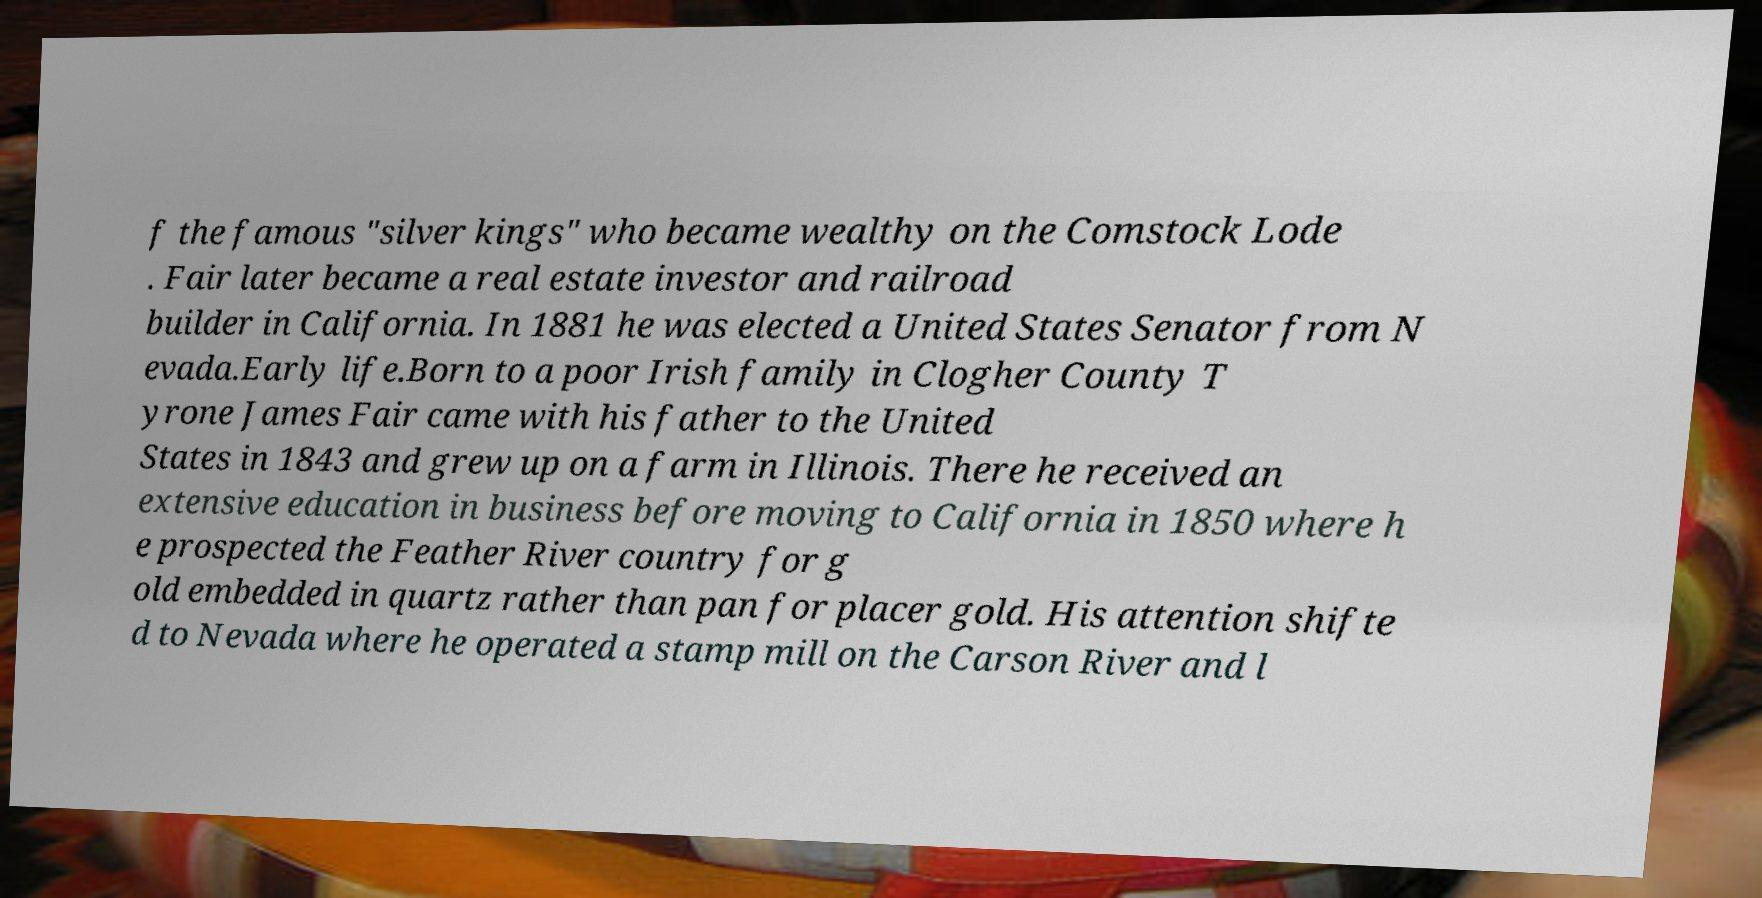Can you accurately transcribe the text from the provided image for me? f the famous "silver kings" who became wealthy on the Comstock Lode . Fair later became a real estate investor and railroad builder in California. In 1881 he was elected a United States Senator from N evada.Early life.Born to a poor Irish family in Clogher County T yrone James Fair came with his father to the United States in 1843 and grew up on a farm in Illinois. There he received an extensive education in business before moving to California in 1850 where h e prospected the Feather River country for g old embedded in quartz rather than pan for placer gold. His attention shifte d to Nevada where he operated a stamp mill on the Carson River and l 